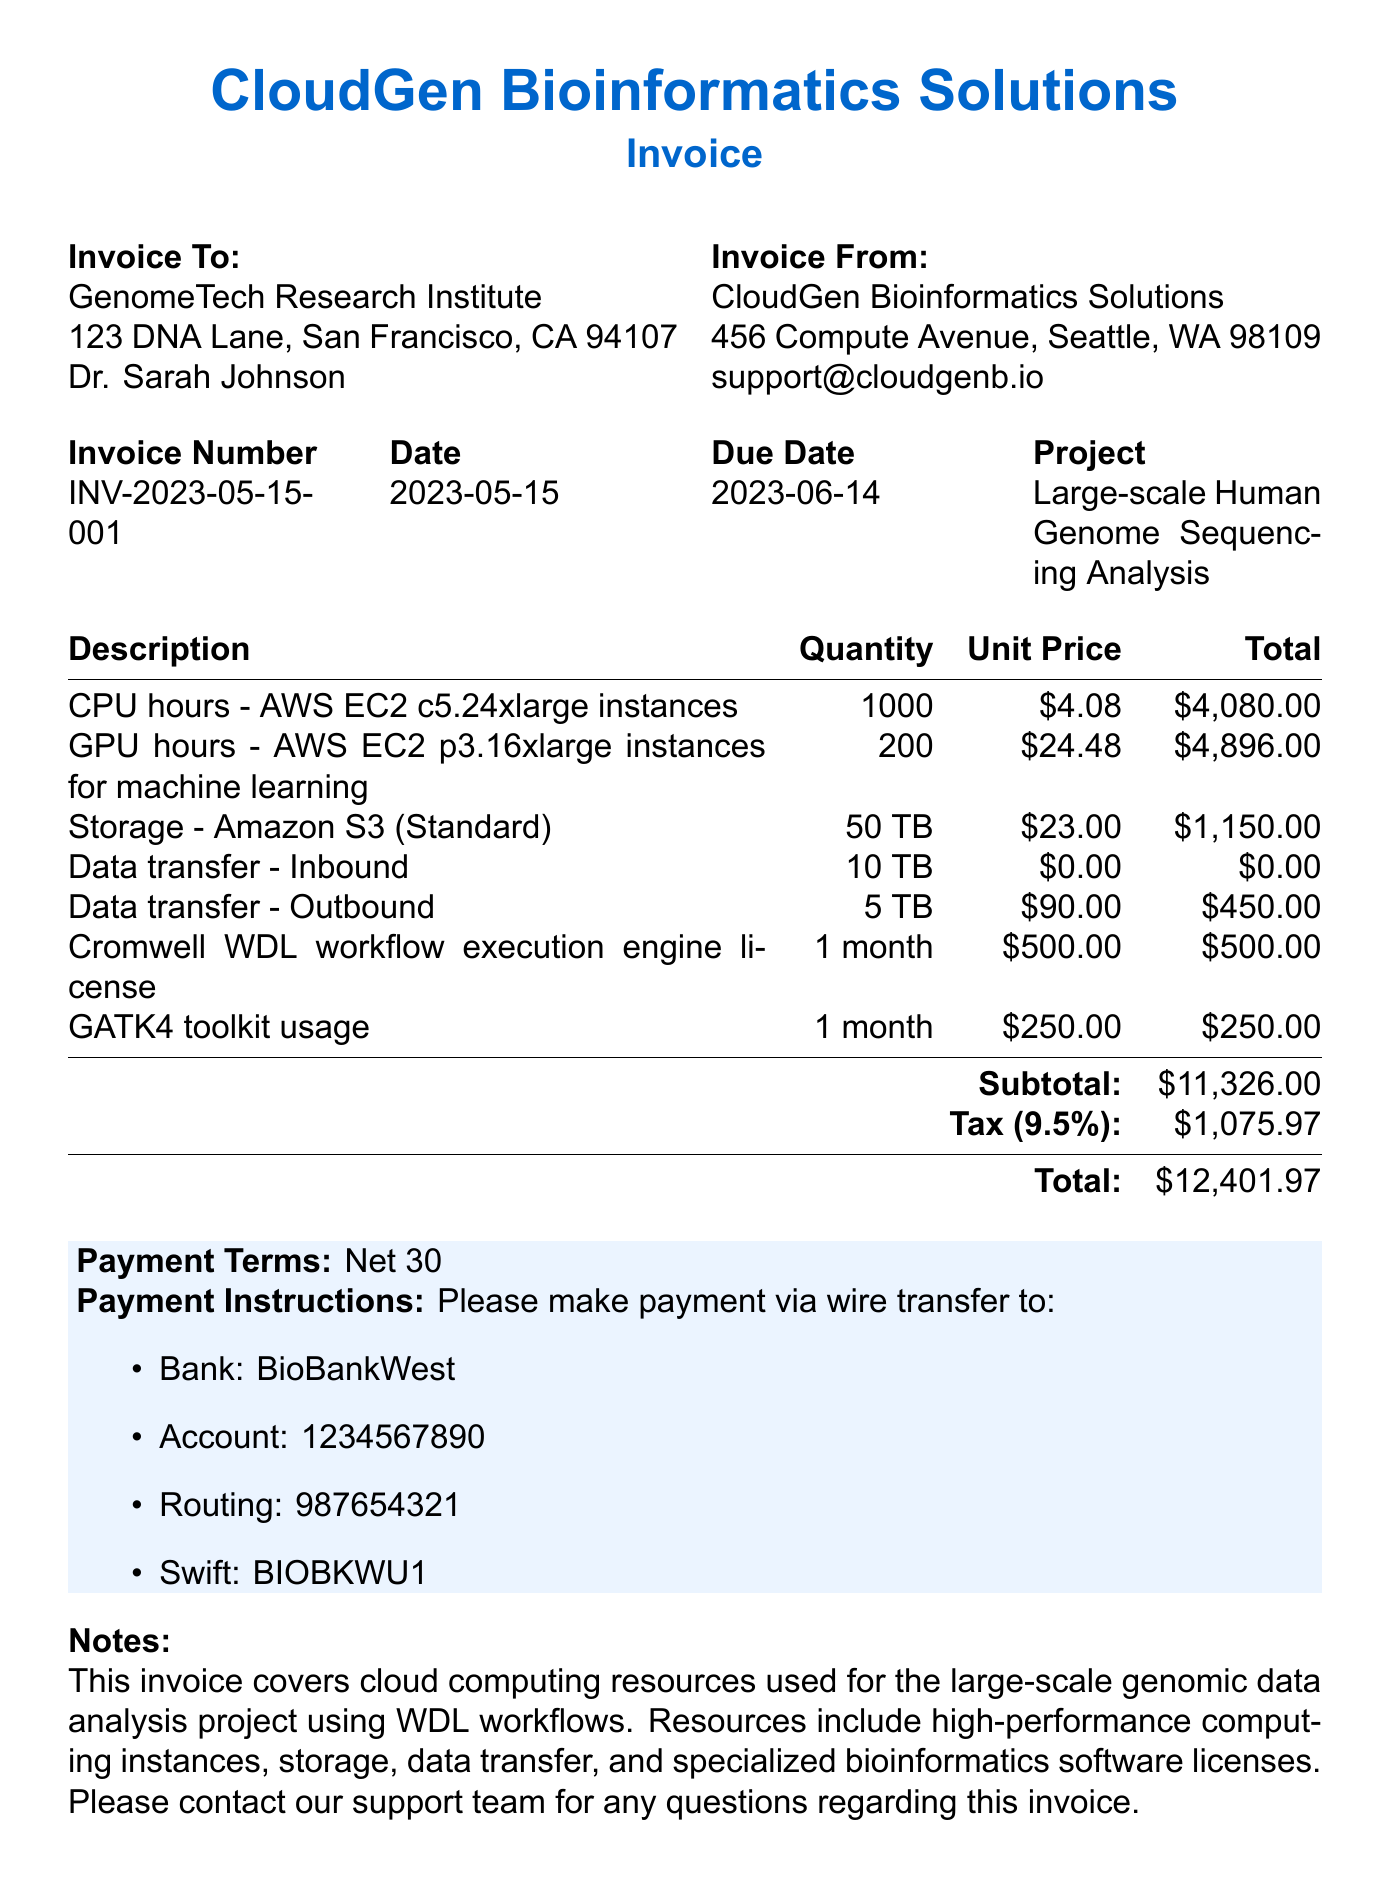What is the invoice number? The invoice number is stated in the document under "Invoice Number."
Answer: INV-2023-05-15-001 Who is the contact person for the client? The contact person for the client is mentioned in the "Invoice To" section.
Answer: Dr. Sarah Johnson What is the total amount due? The total amount due is listed at the bottom of the invoice as the "Total."
Answer: $12,401.97 How many CPU hours were billed? The quantity of CPU hours is provided in the "Description" section of the items listed.
Answer: 1000 What is the unit price for GPU hours? The unit price for GPU hours is detailed under the "Description" section.
Answer: $24.48 What is the tax rate applied? The tax rate is specified in the invoice as part of the summaries at the bottom.
Answer: 9.5% What payment terms are specified? Payment terms are included in the "Payment Terms" section of the invoice.
Answer: Net 30 What is the total charge for storage? The total charge for storage is calculated and shown in the items section.
Answer: $1,150.00 What service is offered for the Cromwell license? The service is detailed in the item list under the description for the Cromwell license.
Answer: Cromwell WDL workflow execution engine license 